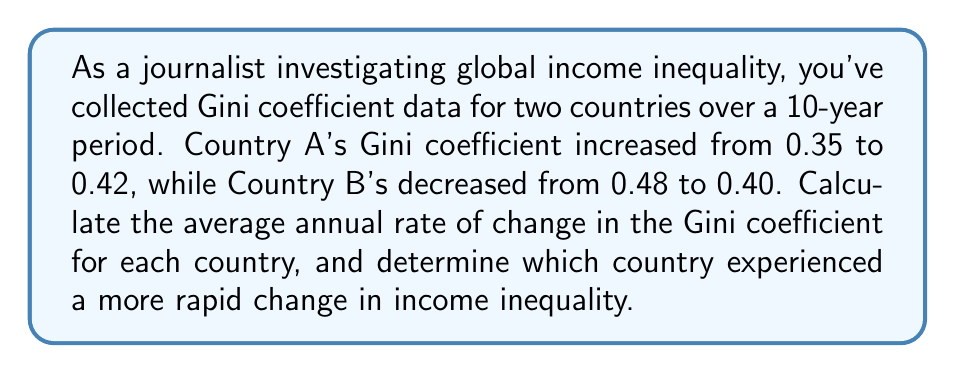Give your solution to this math problem. Let's approach this step-by-step:

1) First, we need to calculate the total change in Gini coefficient for each country:

   Country A: $0.42 - 0.35 = 0.07$ (increase)
   Country B: $0.40 - 0.48 = -0.08$ (decrease)

2) To find the average annual rate of change, we divide the total change by the number of years (10):

   Country A: $\frac{0.07}{10} = 0.007$ per year (increase)
   Country B: $\frac{-0.08}{10} = -0.008$ per year (decrease)

3) To compare the rapidity of change, we need to look at the absolute values:

   Country A: $|0.007| = 0.007$
   Country B: $|-0.008| = 0.008$

4) Since 0.008 > 0.007, Country B experienced a more rapid change in income inequality.

Note: The Gini coefficient ranges from 0 (perfect equality) to 1 (perfect inequality). An increase in the Gini coefficient indicates growing inequality, while a decrease indicates reducing inequality.
Answer: Country B, with an average annual change of -0.008 